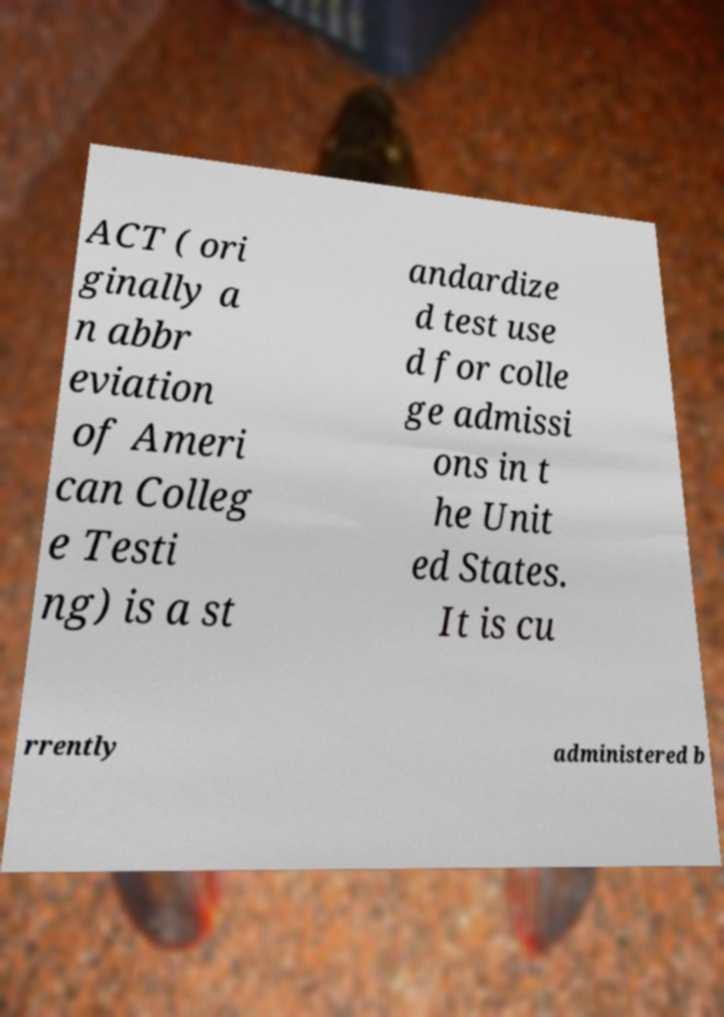For documentation purposes, I need the text within this image transcribed. Could you provide that? ACT ( ori ginally a n abbr eviation of Ameri can Colleg e Testi ng) is a st andardize d test use d for colle ge admissi ons in t he Unit ed States. It is cu rrently administered b 